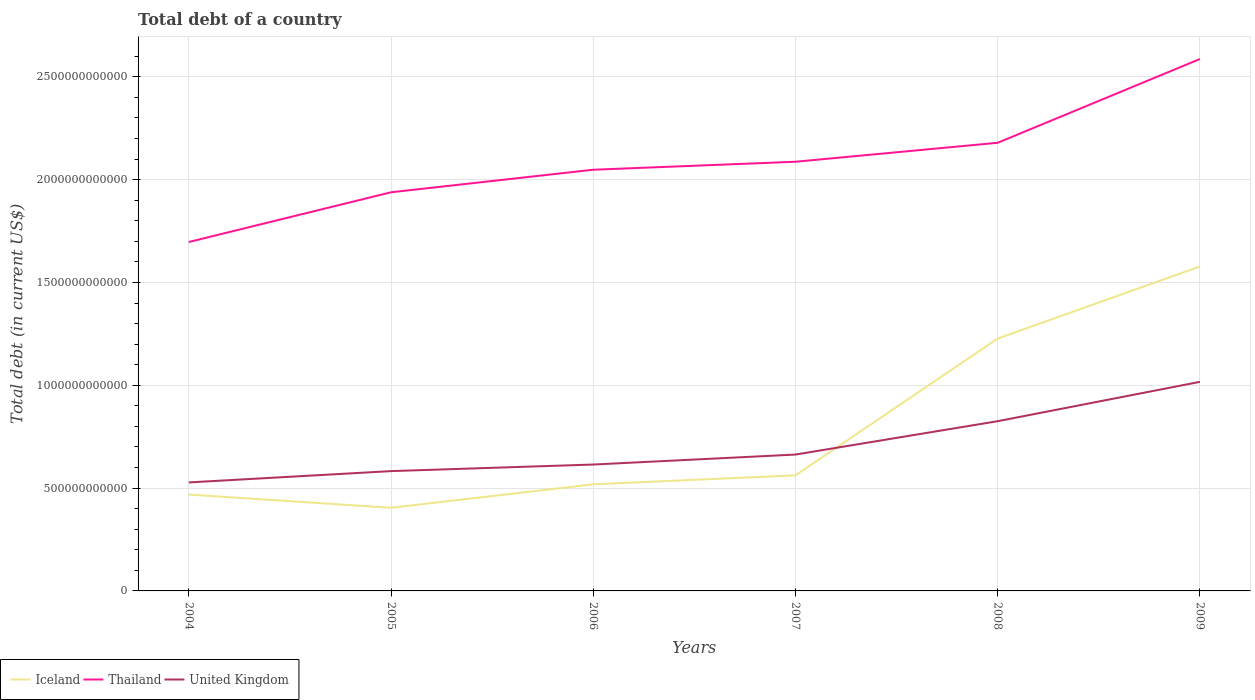How many different coloured lines are there?
Provide a short and direct response. 3. Across all years, what is the maximum debt in Iceland?
Give a very brief answer. 4.04e+11. In which year was the debt in Iceland maximum?
Give a very brief answer. 2005. What is the total debt in United Kingdom in the graph?
Ensure brevity in your answer.  -1.35e+11. What is the difference between the highest and the second highest debt in Thailand?
Provide a short and direct response. 8.90e+11. How many years are there in the graph?
Ensure brevity in your answer.  6. What is the difference between two consecutive major ticks on the Y-axis?
Your answer should be very brief. 5.00e+11. Are the values on the major ticks of Y-axis written in scientific E-notation?
Provide a succinct answer. No. How many legend labels are there?
Give a very brief answer. 3. How are the legend labels stacked?
Your response must be concise. Horizontal. What is the title of the graph?
Provide a short and direct response. Total debt of a country. Does "Belarus" appear as one of the legend labels in the graph?
Provide a succinct answer. No. What is the label or title of the X-axis?
Keep it short and to the point. Years. What is the label or title of the Y-axis?
Give a very brief answer. Total debt (in current US$). What is the Total debt (in current US$) of Iceland in 2004?
Your response must be concise. 4.69e+11. What is the Total debt (in current US$) in Thailand in 2004?
Offer a terse response. 1.70e+12. What is the Total debt (in current US$) in United Kingdom in 2004?
Your answer should be compact. 5.28e+11. What is the Total debt (in current US$) of Iceland in 2005?
Your response must be concise. 4.04e+11. What is the Total debt (in current US$) in Thailand in 2005?
Provide a succinct answer. 1.94e+12. What is the Total debt (in current US$) in United Kingdom in 2005?
Provide a succinct answer. 5.83e+11. What is the Total debt (in current US$) in Iceland in 2006?
Keep it short and to the point. 5.18e+11. What is the Total debt (in current US$) of Thailand in 2006?
Offer a terse response. 2.05e+12. What is the Total debt (in current US$) of United Kingdom in 2006?
Your response must be concise. 6.15e+11. What is the Total debt (in current US$) in Iceland in 2007?
Offer a terse response. 5.62e+11. What is the Total debt (in current US$) in Thailand in 2007?
Make the answer very short. 2.09e+12. What is the Total debt (in current US$) in United Kingdom in 2007?
Offer a very short reply. 6.63e+11. What is the Total debt (in current US$) in Iceland in 2008?
Your answer should be compact. 1.23e+12. What is the Total debt (in current US$) in Thailand in 2008?
Your answer should be very brief. 2.18e+12. What is the Total debt (in current US$) in United Kingdom in 2008?
Offer a terse response. 8.25e+11. What is the Total debt (in current US$) in Iceland in 2009?
Your answer should be compact. 1.58e+12. What is the Total debt (in current US$) of Thailand in 2009?
Make the answer very short. 2.59e+12. What is the Total debt (in current US$) of United Kingdom in 2009?
Your answer should be very brief. 1.02e+12. Across all years, what is the maximum Total debt (in current US$) in Iceland?
Your answer should be compact. 1.58e+12. Across all years, what is the maximum Total debt (in current US$) of Thailand?
Offer a terse response. 2.59e+12. Across all years, what is the maximum Total debt (in current US$) of United Kingdom?
Your response must be concise. 1.02e+12. Across all years, what is the minimum Total debt (in current US$) of Iceland?
Give a very brief answer. 4.04e+11. Across all years, what is the minimum Total debt (in current US$) of Thailand?
Offer a very short reply. 1.70e+12. Across all years, what is the minimum Total debt (in current US$) of United Kingdom?
Give a very brief answer. 5.28e+11. What is the total Total debt (in current US$) of Iceland in the graph?
Make the answer very short. 4.76e+12. What is the total Total debt (in current US$) in Thailand in the graph?
Give a very brief answer. 1.25e+13. What is the total Total debt (in current US$) in United Kingdom in the graph?
Provide a short and direct response. 4.23e+12. What is the difference between the Total debt (in current US$) in Iceland in 2004 and that in 2005?
Give a very brief answer. 6.42e+1. What is the difference between the Total debt (in current US$) in Thailand in 2004 and that in 2005?
Provide a short and direct response. -2.42e+11. What is the difference between the Total debt (in current US$) of United Kingdom in 2004 and that in 2005?
Keep it short and to the point. -5.50e+1. What is the difference between the Total debt (in current US$) of Iceland in 2004 and that in 2006?
Offer a terse response. -4.99e+1. What is the difference between the Total debt (in current US$) of Thailand in 2004 and that in 2006?
Provide a short and direct response. -3.52e+11. What is the difference between the Total debt (in current US$) in United Kingdom in 2004 and that in 2006?
Give a very brief answer. -8.70e+1. What is the difference between the Total debt (in current US$) of Iceland in 2004 and that in 2007?
Offer a terse response. -9.35e+1. What is the difference between the Total debt (in current US$) of Thailand in 2004 and that in 2007?
Provide a succinct answer. -3.90e+11. What is the difference between the Total debt (in current US$) in United Kingdom in 2004 and that in 2007?
Your response must be concise. -1.35e+11. What is the difference between the Total debt (in current US$) in Iceland in 2004 and that in 2008?
Ensure brevity in your answer.  -7.59e+11. What is the difference between the Total debt (in current US$) of Thailand in 2004 and that in 2008?
Make the answer very short. -4.83e+11. What is the difference between the Total debt (in current US$) of United Kingdom in 2004 and that in 2008?
Your answer should be very brief. -2.98e+11. What is the difference between the Total debt (in current US$) of Iceland in 2004 and that in 2009?
Ensure brevity in your answer.  -1.11e+12. What is the difference between the Total debt (in current US$) of Thailand in 2004 and that in 2009?
Give a very brief answer. -8.90e+11. What is the difference between the Total debt (in current US$) of United Kingdom in 2004 and that in 2009?
Your response must be concise. -4.89e+11. What is the difference between the Total debt (in current US$) of Iceland in 2005 and that in 2006?
Provide a succinct answer. -1.14e+11. What is the difference between the Total debt (in current US$) in Thailand in 2005 and that in 2006?
Offer a terse response. -1.10e+11. What is the difference between the Total debt (in current US$) of United Kingdom in 2005 and that in 2006?
Your answer should be compact. -3.20e+1. What is the difference between the Total debt (in current US$) in Iceland in 2005 and that in 2007?
Give a very brief answer. -1.58e+11. What is the difference between the Total debt (in current US$) of Thailand in 2005 and that in 2007?
Your response must be concise. -1.48e+11. What is the difference between the Total debt (in current US$) in United Kingdom in 2005 and that in 2007?
Your answer should be compact. -8.05e+1. What is the difference between the Total debt (in current US$) in Iceland in 2005 and that in 2008?
Your response must be concise. -8.23e+11. What is the difference between the Total debt (in current US$) of Thailand in 2005 and that in 2008?
Your answer should be compact. -2.41e+11. What is the difference between the Total debt (in current US$) of United Kingdom in 2005 and that in 2008?
Offer a very short reply. -2.43e+11. What is the difference between the Total debt (in current US$) in Iceland in 2005 and that in 2009?
Your answer should be compact. -1.17e+12. What is the difference between the Total debt (in current US$) of Thailand in 2005 and that in 2009?
Give a very brief answer. -6.48e+11. What is the difference between the Total debt (in current US$) in United Kingdom in 2005 and that in 2009?
Your response must be concise. -4.34e+11. What is the difference between the Total debt (in current US$) in Iceland in 2006 and that in 2007?
Offer a very short reply. -4.37e+1. What is the difference between the Total debt (in current US$) of Thailand in 2006 and that in 2007?
Your response must be concise. -3.88e+1. What is the difference between the Total debt (in current US$) of United Kingdom in 2006 and that in 2007?
Offer a terse response. -4.85e+1. What is the difference between the Total debt (in current US$) of Iceland in 2006 and that in 2008?
Offer a very short reply. -7.09e+11. What is the difference between the Total debt (in current US$) of Thailand in 2006 and that in 2008?
Your response must be concise. -1.31e+11. What is the difference between the Total debt (in current US$) in United Kingdom in 2006 and that in 2008?
Offer a very short reply. -2.11e+11. What is the difference between the Total debt (in current US$) of Iceland in 2006 and that in 2009?
Provide a succinct answer. -1.06e+12. What is the difference between the Total debt (in current US$) in Thailand in 2006 and that in 2009?
Your answer should be compact. -5.38e+11. What is the difference between the Total debt (in current US$) of United Kingdom in 2006 and that in 2009?
Offer a terse response. -4.02e+11. What is the difference between the Total debt (in current US$) of Iceland in 2007 and that in 2008?
Provide a succinct answer. -6.65e+11. What is the difference between the Total debt (in current US$) in Thailand in 2007 and that in 2008?
Your response must be concise. -9.23e+1. What is the difference between the Total debt (in current US$) of United Kingdom in 2007 and that in 2008?
Offer a very short reply. -1.62e+11. What is the difference between the Total debt (in current US$) of Iceland in 2007 and that in 2009?
Your answer should be compact. -1.02e+12. What is the difference between the Total debt (in current US$) of Thailand in 2007 and that in 2009?
Ensure brevity in your answer.  -5.00e+11. What is the difference between the Total debt (in current US$) in United Kingdom in 2007 and that in 2009?
Offer a very short reply. -3.54e+11. What is the difference between the Total debt (in current US$) in Iceland in 2008 and that in 2009?
Offer a very short reply. -3.50e+11. What is the difference between the Total debt (in current US$) in Thailand in 2008 and that in 2009?
Offer a terse response. -4.07e+11. What is the difference between the Total debt (in current US$) in United Kingdom in 2008 and that in 2009?
Your response must be concise. -1.91e+11. What is the difference between the Total debt (in current US$) of Iceland in 2004 and the Total debt (in current US$) of Thailand in 2005?
Provide a short and direct response. -1.47e+12. What is the difference between the Total debt (in current US$) of Iceland in 2004 and the Total debt (in current US$) of United Kingdom in 2005?
Make the answer very short. -1.14e+11. What is the difference between the Total debt (in current US$) in Thailand in 2004 and the Total debt (in current US$) in United Kingdom in 2005?
Keep it short and to the point. 1.11e+12. What is the difference between the Total debt (in current US$) of Iceland in 2004 and the Total debt (in current US$) of Thailand in 2006?
Your response must be concise. -1.58e+12. What is the difference between the Total debt (in current US$) of Iceland in 2004 and the Total debt (in current US$) of United Kingdom in 2006?
Ensure brevity in your answer.  -1.46e+11. What is the difference between the Total debt (in current US$) in Thailand in 2004 and the Total debt (in current US$) in United Kingdom in 2006?
Ensure brevity in your answer.  1.08e+12. What is the difference between the Total debt (in current US$) in Iceland in 2004 and the Total debt (in current US$) in Thailand in 2007?
Offer a very short reply. -1.62e+12. What is the difference between the Total debt (in current US$) of Iceland in 2004 and the Total debt (in current US$) of United Kingdom in 2007?
Offer a terse response. -1.95e+11. What is the difference between the Total debt (in current US$) of Thailand in 2004 and the Total debt (in current US$) of United Kingdom in 2007?
Ensure brevity in your answer.  1.03e+12. What is the difference between the Total debt (in current US$) in Iceland in 2004 and the Total debt (in current US$) in Thailand in 2008?
Provide a succinct answer. -1.71e+12. What is the difference between the Total debt (in current US$) in Iceland in 2004 and the Total debt (in current US$) in United Kingdom in 2008?
Ensure brevity in your answer.  -3.57e+11. What is the difference between the Total debt (in current US$) of Thailand in 2004 and the Total debt (in current US$) of United Kingdom in 2008?
Give a very brief answer. 8.71e+11. What is the difference between the Total debt (in current US$) in Iceland in 2004 and the Total debt (in current US$) in Thailand in 2009?
Your response must be concise. -2.12e+12. What is the difference between the Total debt (in current US$) in Iceland in 2004 and the Total debt (in current US$) in United Kingdom in 2009?
Make the answer very short. -5.48e+11. What is the difference between the Total debt (in current US$) in Thailand in 2004 and the Total debt (in current US$) in United Kingdom in 2009?
Your response must be concise. 6.80e+11. What is the difference between the Total debt (in current US$) of Iceland in 2005 and the Total debt (in current US$) of Thailand in 2006?
Offer a very short reply. -1.64e+12. What is the difference between the Total debt (in current US$) in Iceland in 2005 and the Total debt (in current US$) in United Kingdom in 2006?
Offer a very short reply. -2.10e+11. What is the difference between the Total debt (in current US$) of Thailand in 2005 and the Total debt (in current US$) of United Kingdom in 2006?
Your response must be concise. 1.32e+12. What is the difference between the Total debt (in current US$) in Iceland in 2005 and the Total debt (in current US$) in Thailand in 2007?
Your answer should be compact. -1.68e+12. What is the difference between the Total debt (in current US$) of Iceland in 2005 and the Total debt (in current US$) of United Kingdom in 2007?
Offer a very short reply. -2.59e+11. What is the difference between the Total debt (in current US$) in Thailand in 2005 and the Total debt (in current US$) in United Kingdom in 2007?
Your answer should be very brief. 1.28e+12. What is the difference between the Total debt (in current US$) in Iceland in 2005 and the Total debt (in current US$) in Thailand in 2008?
Give a very brief answer. -1.77e+12. What is the difference between the Total debt (in current US$) of Iceland in 2005 and the Total debt (in current US$) of United Kingdom in 2008?
Keep it short and to the point. -4.21e+11. What is the difference between the Total debt (in current US$) in Thailand in 2005 and the Total debt (in current US$) in United Kingdom in 2008?
Offer a terse response. 1.11e+12. What is the difference between the Total debt (in current US$) in Iceland in 2005 and the Total debt (in current US$) in Thailand in 2009?
Ensure brevity in your answer.  -2.18e+12. What is the difference between the Total debt (in current US$) of Iceland in 2005 and the Total debt (in current US$) of United Kingdom in 2009?
Keep it short and to the point. -6.12e+11. What is the difference between the Total debt (in current US$) in Thailand in 2005 and the Total debt (in current US$) in United Kingdom in 2009?
Offer a terse response. 9.22e+11. What is the difference between the Total debt (in current US$) of Iceland in 2006 and the Total debt (in current US$) of Thailand in 2007?
Your answer should be very brief. -1.57e+12. What is the difference between the Total debt (in current US$) of Iceland in 2006 and the Total debt (in current US$) of United Kingdom in 2007?
Your answer should be compact. -1.45e+11. What is the difference between the Total debt (in current US$) in Thailand in 2006 and the Total debt (in current US$) in United Kingdom in 2007?
Your answer should be very brief. 1.39e+12. What is the difference between the Total debt (in current US$) of Iceland in 2006 and the Total debt (in current US$) of Thailand in 2008?
Make the answer very short. -1.66e+12. What is the difference between the Total debt (in current US$) in Iceland in 2006 and the Total debt (in current US$) in United Kingdom in 2008?
Offer a terse response. -3.07e+11. What is the difference between the Total debt (in current US$) of Thailand in 2006 and the Total debt (in current US$) of United Kingdom in 2008?
Offer a terse response. 1.22e+12. What is the difference between the Total debt (in current US$) of Iceland in 2006 and the Total debt (in current US$) of Thailand in 2009?
Your response must be concise. -2.07e+12. What is the difference between the Total debt (in current US$) of Iceland in 2006 and the Total debt (in current US$) of United Kingdom in 2009?
Your answer should be very brief. -4.98e+11. What is the difference between the Total debt (in current US$) in Thailand in 2006 and the Total debt (in current US$) in United Kingdom in 2009?
Offer a terse response. 1.03e+12. What is the difference between the Total debt (in current US$) in Iceland in 2007 and the Total debt (in current US$) in Thailand in 2008?
Provide a short and direct response. -1.62e+12. What is the difference between the Total debt (in current US$) in Iceland in 2007 and the Total debt (in current US$) in United Kingdom in 2008?
Ensure brevity in your answer.  -2.63e+11. What is the difference between the Total debt (in current US$) of Thailand in 2007 and the Total debt (in current US$) of United Kingdom in 2008?
Ensure brevity in your answer.  1.26e+12. What is the difference between the Total debt (in current US$) of Iceland in 2007 and the Total debt (in current US$) of Thailand in 2009?
Offer a very short reply. -2.02e+12. What is the difference between the Total debt (in current US$) in Iceland in 2007 and the Total debt (in current US$) in United Kingdom in 2009?
Your response must be concise. -4.55e+11. What is the difference between the Total debt (in current US$) of Thailand in 2007 and the Total debt (in current US$) of United Kingdom in 2009?
Offer a terse response. 1.07e+12. What is the difference between the Total debt (in current US$) of Iceland in 2008 and the Total debt (in current US$) of Thailand in 2009?
Ensure brevity in your answer.  -1.36e+12. What is the difference between the Total debt (in current US$) in Iceland in 2008 and the Total debt (in current US$) in United Kingdom in 2009?
Your answer should be compact. 2.11e+11. What is the difference between the Total debt (in current US$) of Thailand in 2008 and the Total debt (in current US$) of United Kingdom in 2009?
Keep it short and to the point. 1.16e+12. What is the average Total debt (in current US$) in Iceland per year?
Offer a very short reply. 7.93e+11. What is the average Total debt (in current US$) in Thailand per year?
Your response must be concise. 2.09e+12. What is the average Total debt (in current US$) in United Kingdom per year?
Keep it short and to the point. 7.05e+11. In the year 2004, what is the difference between the Total debt (in current US$) of Iceland and Total debt (in current US$) of Thailand?
Offer a very short reply. -1.23e+12. In the year 2004, what is the difference between the Total debt (in current US$) in Iceland and Total debt (in current US$) in United Kingdom?
Provide a succinct answer. -5.91e+1. In the year 2004, what is the difference between the Total debt (in current US$) of Thailand and Total debt (in current US$) of United Kingdom?
Give a very brief answer. 1.17e+12. In the year 2005, what is the difference between the Total debt (in current US$) of Iceland and Total debt (in current US$) of Thailand?
Your answer should be compact. -1.53e+12. In the year 2005, what is the difference between the Total debt (in current US$) in Iceland and Total debt (in current US$) in United Kingdom?
Your answer should be very brief. -1.78e+11. In the year 2005, what is the difference between the Total debt (in current US$) of Thailand and Total debt (in current US$) of United Kingdom?
Your answer should be compact. 1.36e+12. In the year 2006, what is the difference between the Total debt (in current US$) in Iceland and Total debt (in current US$) in Thailand?
Offer a very short reply. -1.53e+12. In the year 2006, what is the difference between the Total debt (in current US$) in Iceland and Total debt (in current US$) in United Kingdom?
Ensure brevity in your answer.  -9.62e+1. In the year 2006, what is the difference between the Total debt (in current US$) of Thailand and Total debt (in current US$) of United Kingdom?
Make the answer very short. 1.43e+12. In the year 2007, what is the difference between the Total debt (in current US$) of Iceland and Total debt (in current US$) of Thailand?
Provide a succinct answer. -1.52e+12. In the year 2007, what is the difference between the Total debt (in current US$) in Iceland and Total debt (in current US$) in United Kingdom?
Offer a terse response. -1.01e+11. In the year 2007, what is the difference between the Total debt (in current US$) of Thailand and Total debt (in current US$) of United Kingdom?
Offer a terse response. 1.42e+12. In the year 2008, what is the difference between the Total debt (in current US$) of Iceland and Total debt (in current US$) of Thailand?
Offer a terse response. -9.52e+11. In the year 2008, what is the difference between the Total debt (in current US$) of Iceland and Total debt (in current US$) of United Kingdom?
Offer a very short reply. 4.02e+11. In the year 2008, what is the difference between the Total debt (in current US$) in Thailand and Total debt (in current US$) in United Kingdom?
Offer a terse response. 1.35e+12. In the year 2009, what is the difference between the Total debt (in current US$) in Iceland and Total debt (in current US$) in Thailand?
Provide a short and direct response. -1.01e+12. In the year 2009, what is the difference between the Total debt (in current US$) of Iceland and Total debt (in current US$) of United Kingdom?
Provide a succinct answer. 5.61e+11. In the year 2009, what is the difference between the Total debt (in current US$) in Thailand and Total debt (in current US$) in United Kingdom?
Give a very brief answer. 1.57e+12. What is the ratio of the Total debt (in current US$) of Iceland in 2004 to that in 2005?
Ensure brevity in your answer.  1.16. What is the ratio of the Total debt (in current US$) of Thailand in 2004 to that in 2005?
Make the answer very short. 0.88. What is the ratio of the Total debt (in current US$) in United Kingdom in 2004 to that in 2005?
Give a very brief answer. 0.91. What is the ratio of the Total debt (in current US$) of Iceland in 2004 to that in 2006?
Your response must be concise. 0.9. What is the ratio of the Total debt (in current US$) in Thailand in 2004 to that in 2006?
Give a very brief answer. 0.83. What is the ratio of the Total debt (in current US$) in United Kingdom in 2004 to that in 2006?
Offer a very short reply. 0.86. What is the ratio of the Total debt (in current US$) of Iceland in 2004 to that in 2007?
Your answer should be very brief. 0.83. What is the ratio of the Total debt (in current US$) of Thailand in 2004 to that in 2007?
Make the answer very short. 0.81. What is the ratio of the Total debt (in current US$) of United Kingdom in 2004 to that in 2007?
Offer a terse response. 0.8. What is the ratio of the Total debt (in current US$) in Iceland in 2004 to that in 2008?
Your response must be concise. 0.38. What is the ratio of the Total debt (in current US$) in Thailand in 2004 to that in 2008?
Your answer should be very brief. 0.78. What is the ratio of the Total debt (in current US$) in United Kingdom in 2004 to that in 2008?
Offer a very short reply. 0.64. What is the ratio of the Total debt (in current US$) of Iceland in 2004 to that in 2009?
Your response must be concise. 0.3. What is the ratio of the Total debt (in current US$) in Thailand in 2004 to that in 2009?
Ensure brevity in your answer.  0.66. What is the ratio of the Total debt (in current US$) of United Kingdom in 2004 to that in 2009?
Your answer should be very brief. 0.52. What is the ratio of the Total debt (in current US$) in Iceland in 2005 to that in 2006?
Your answer should be very brief. 0.78. What is the ratio of the Total debt (in current US$) in Thailand in 2005 to that in 2006?
Offer a very short reply. 0.95. What is the ratio of the Total debt (in current US$) of United Kingdom in 2005 to that in 2006?
Provide a short and direct response. 0.95. What is the ratio of the Total debt (in current US$) of Iceland in 2005 to that in 2007?
Your response must be concise. 0.72. What is the ratio of the Total debt (in current US$) in Thailand in 2005 to that in 2007?
Ensure brevity in your answer.  0.93. What is the ratio of the Total debt (in current US$) in United Kingdom in 2005 to that in 2007?
Give a very brief answer. 0.88. What is the ratio of the Total debt (in current US$) in Iceland in 2005 to that in 2008?
Your response must be concise. 0.33. What is the ratio of the Total debt (in current US$) in Thailand in 2005 to that in 2008?
Provide a short and direct response. 0.89. What is the ratio of the Total debt (in current US$) of United Kingdom in 2005 to that in 2008?
Offer a terse response. 0.71. What is the ratio of the Total debt (in current US$) in Iceland in 2005 to that in 2009?
Your answer should be compact. 0.26. What is the ratio of the Total debt (in current US$) of Thailand in 2005 to that in 2009?
Provide a succinct answer. 0.75. What is the ratio of the Total debt (in current US$) of United Kingdom in 2005 to that in 2009?
Make the answer very short. 0.57. What is the ratio of the Total debt (in current US$) in Iceland in 2006 to that in 2007?
Your answer should be compact. 0.92. What is the ratio of the Total debt (in current US$) of Thailand in 2006 to that in 2007?
Keep it short and to the point. 0.98. What is the ratio of the Total debt (in current US$) of United Kingdom in 2006 to that in 2007?
Provide a succinct answer. 0.93. What is the ratio of the Total debt (in current US$) in Iceland in 2006 to that in 2008?
Offer a terse response. 0.42. What is the ratio of the Total debt (in current US$) of Thailand in 2006 to that in 2008?
Your answer should be compact. 0.94. What is the ratio of the Total debt (in current US$) in United Kingdom in 2006 to that in 2008?
Provide a short and direct response. 0.74. What is the ratio of the Total debt (in current US$) in Iceland in 2006 to that in 2009?
Your response must be concise. 0.33. What is the ratio of the Total debt (in current US$) of Thailand in 2006 to that in 2009?
Keep it short and to the point. 0.79. What is the ratio of the Total debt (in current US$) in United Kingdom in 2006 to that in 2009?
Your answer should be compact. 0.6. What is the ratio of the Total debt (in current US$) in Iceland in 2007 to that in 2008?
Your answer should be very brief. 0.46. What is the ratio of the Total debt (in current US$) of Thailand in 2007 to that in 2008?
Provide a short and direct response. 0.96. What is the ratio of the Total debt (in current US$) in United Kingdom in 2007 to that in 2008?
Provide a succinct answer. 0.8. What is the ratio of the Total debt (in current US$) in Iceland in 2007 to that in 2009?
Make the answer very short. 0.36. What is the ratio of the Total debt (in current US$) in Thailand in 2007 to that in 2009?
Your answer should be compact. 0.81. What is the ratio of the Total debt (in current US$) of United Kingdom in 2007 to that in 2009?
Your response must be concise. 0.65. What is the ratio of the Total debt (in current US$) in Iceland in 2008 to that in 2009?
Make the answer very short. 0.78. What is the ratio of the Total debt (in current US$) in Thailand in 2008 to that in 2009?
Your answer should be compact. 0.84. What is the ratio of the Total debt (in current US$) in United Kingdom in 2008 to that in 2009?
Make the answer very short. 0.81. What is the difference between the highest and the second highest Total debt (in current US$) of Iceland?
Ensure brevity in your answer.  3.50e+11. What is the difference between the highest and the second highest Total debt (in current US$) of Thailand?
Your answer should be compact. 4.07e+11. What is the difference between the highest and the second highest Total debt (in current US$) of United Kingdom?
Offer a very short reply. 1.91e+11. What is the difference between the highest and the lowest Total debt (in current US$) of Iceland?
Offer a very short reply. 1.17e+12. What is the difference between the highest and the lowest Total debt (in current US$) in Thailand?
Offer a terse response. 8.90e+11. What is the difference between the highest and the lowest Total debt (in current US$) of United Kingdom?
Offer a terse response. 4.89e+11. 